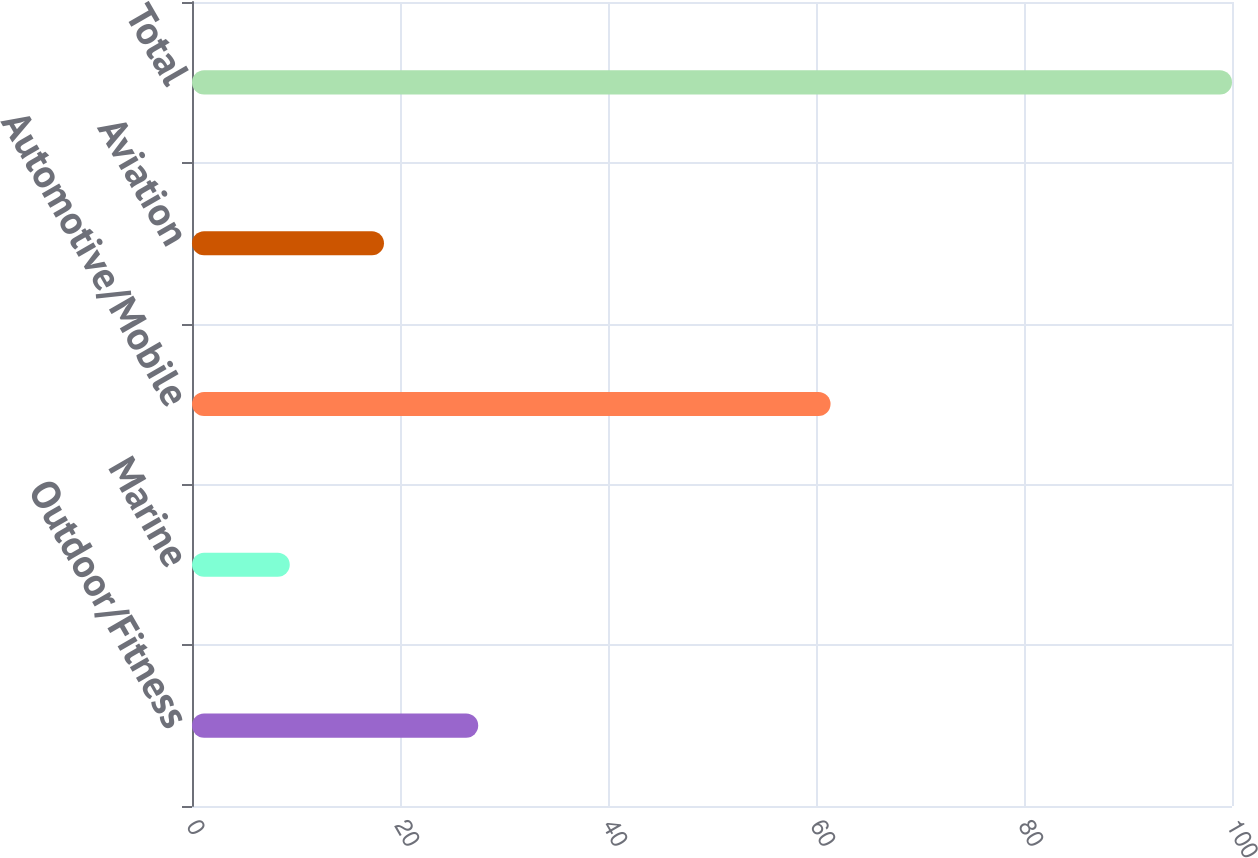<chart> <loc_0><loc_0><loc_500><loc_500><bar_chart><fcel>Outdoor/Fitness<fcel>Marine<fcel>Automotive/Mobile<fcel>Aviation<fcel>Total<nl><fcel>27.52<fcel>9.4<fcel>61.4<fcel>18.46<fcel>100<nl></chart> 